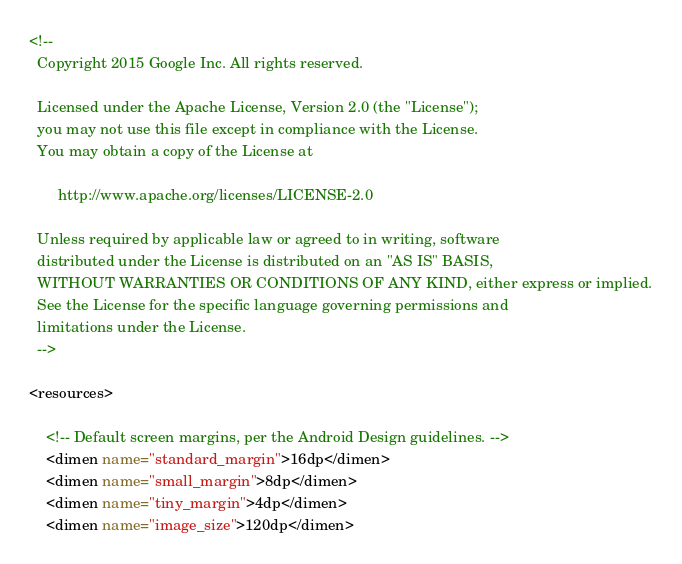<code> <loc_0><loc_0><loc_500><loc_500><_XML_><!--
  Copyright 2015 Google Inc. All rights reserved.

  Licensed under the Apache License, Version 2.0 (the "License");
  you may not use this file except in compliance with the License.
  You may obtain a copy of the License at

       http://www.apache.org/licenses/LICENSE-2.0

  Unless required by applicable law or agreed to in writing, software
  distributed under the License is distributed on an "AS IS" BASIS,
  WITHOUT WARRANTIES OR CONDITIONS OF ANY KIND, either express or implied.
  See the License for the specific language governing permissions and
  limitations under the License.
  -->

<resources>

    <!-- Default screen margins, per the Android Design guidelines. -->
    <dimen name="standard_margin">16dp</dimen>
    <dimen name="small_margin">8dp</dimen>
    <dimen name="tiny_margin">4dp</dimen>
    <dimen name="image_size">120dp</dimen></code> 